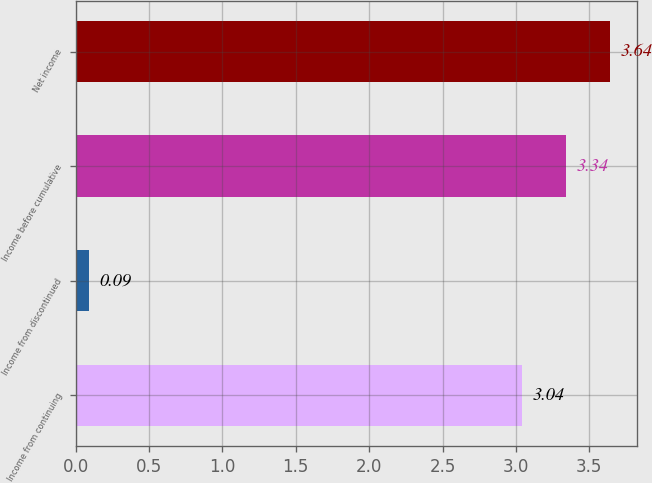Convert chart to OTSL. <chart><loc_0><loc_0><loc_500><loc_500><bar_chart><fcel>Income from continuing<fcel>Income from discontinued<fcel>Income before cumulative<fcel>Net income<nl><fcel>3.04<fcel>0.09<fcel>3.34<fcel>3.64<nl></chart> 